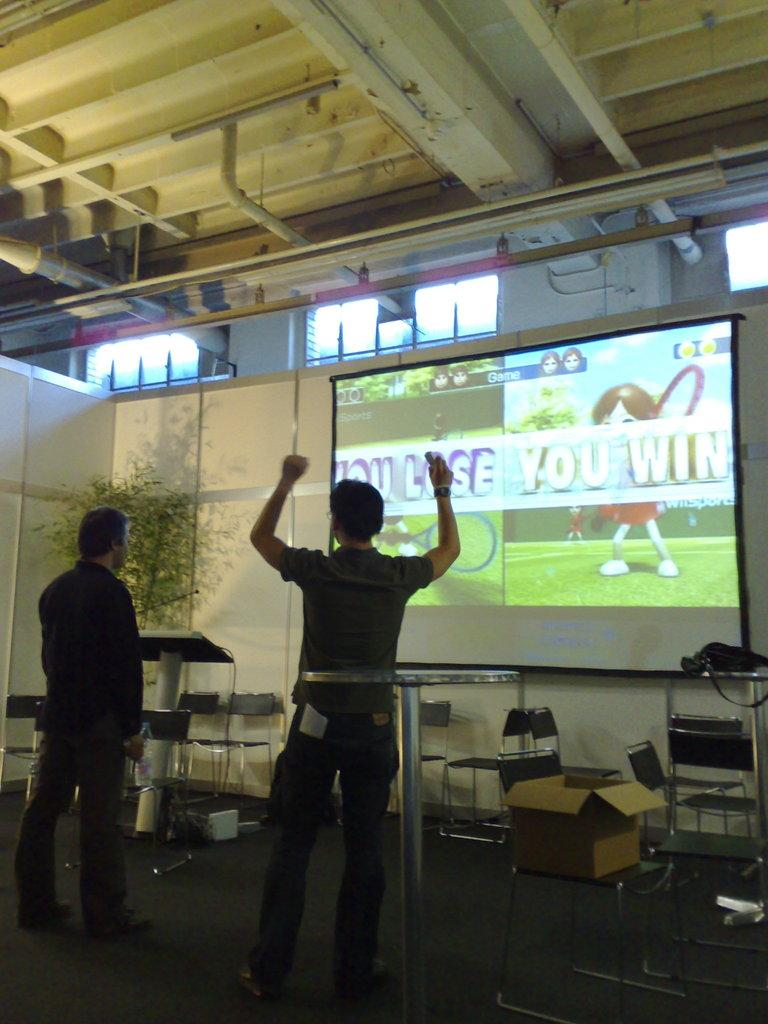<image>
Provide a brief description of the given image. Two men, one celebrating, standing in front of a win and loss image being projected on a screen. 